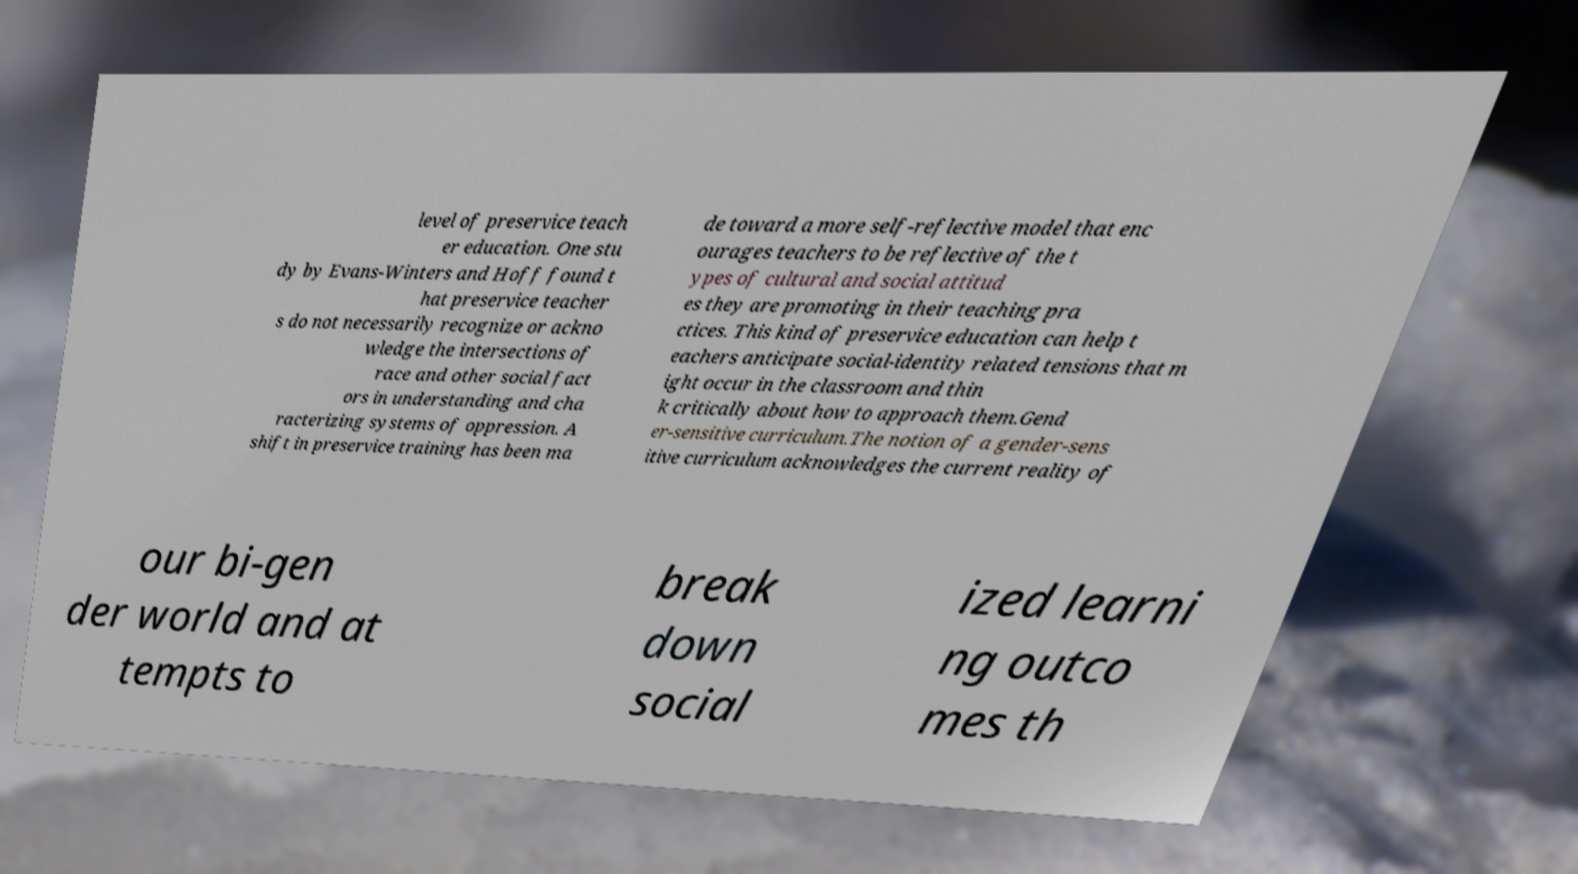What messages or text are displayed in this image? I need them in a readable, typed format. level of preservice teach er education. One stu dy by Evans-Winters and Hoff found t hat preservice teacher s do not necessarily recognize or ackno wledge the intersections of race and other social fact ors in understanding and cha racterizing systems of oppression. A shift in preservice training has been ma de toward a more self-reflective model that enc ourages teachers to be reflective of the t ypes of cultural and social attitud es they are promoting in their teaching pra ctices. This kind of preservice education can help t eachers anticipate social-identity related tensions that m ight occur in the classroom and thin k critically about how to approach them.Gend er-sensitive curriculum.The notion of a gender-sens itive curriculum acknowledges the current reality of our bi-gen der world and at tempts to break down social ized learni ng outco mes th 